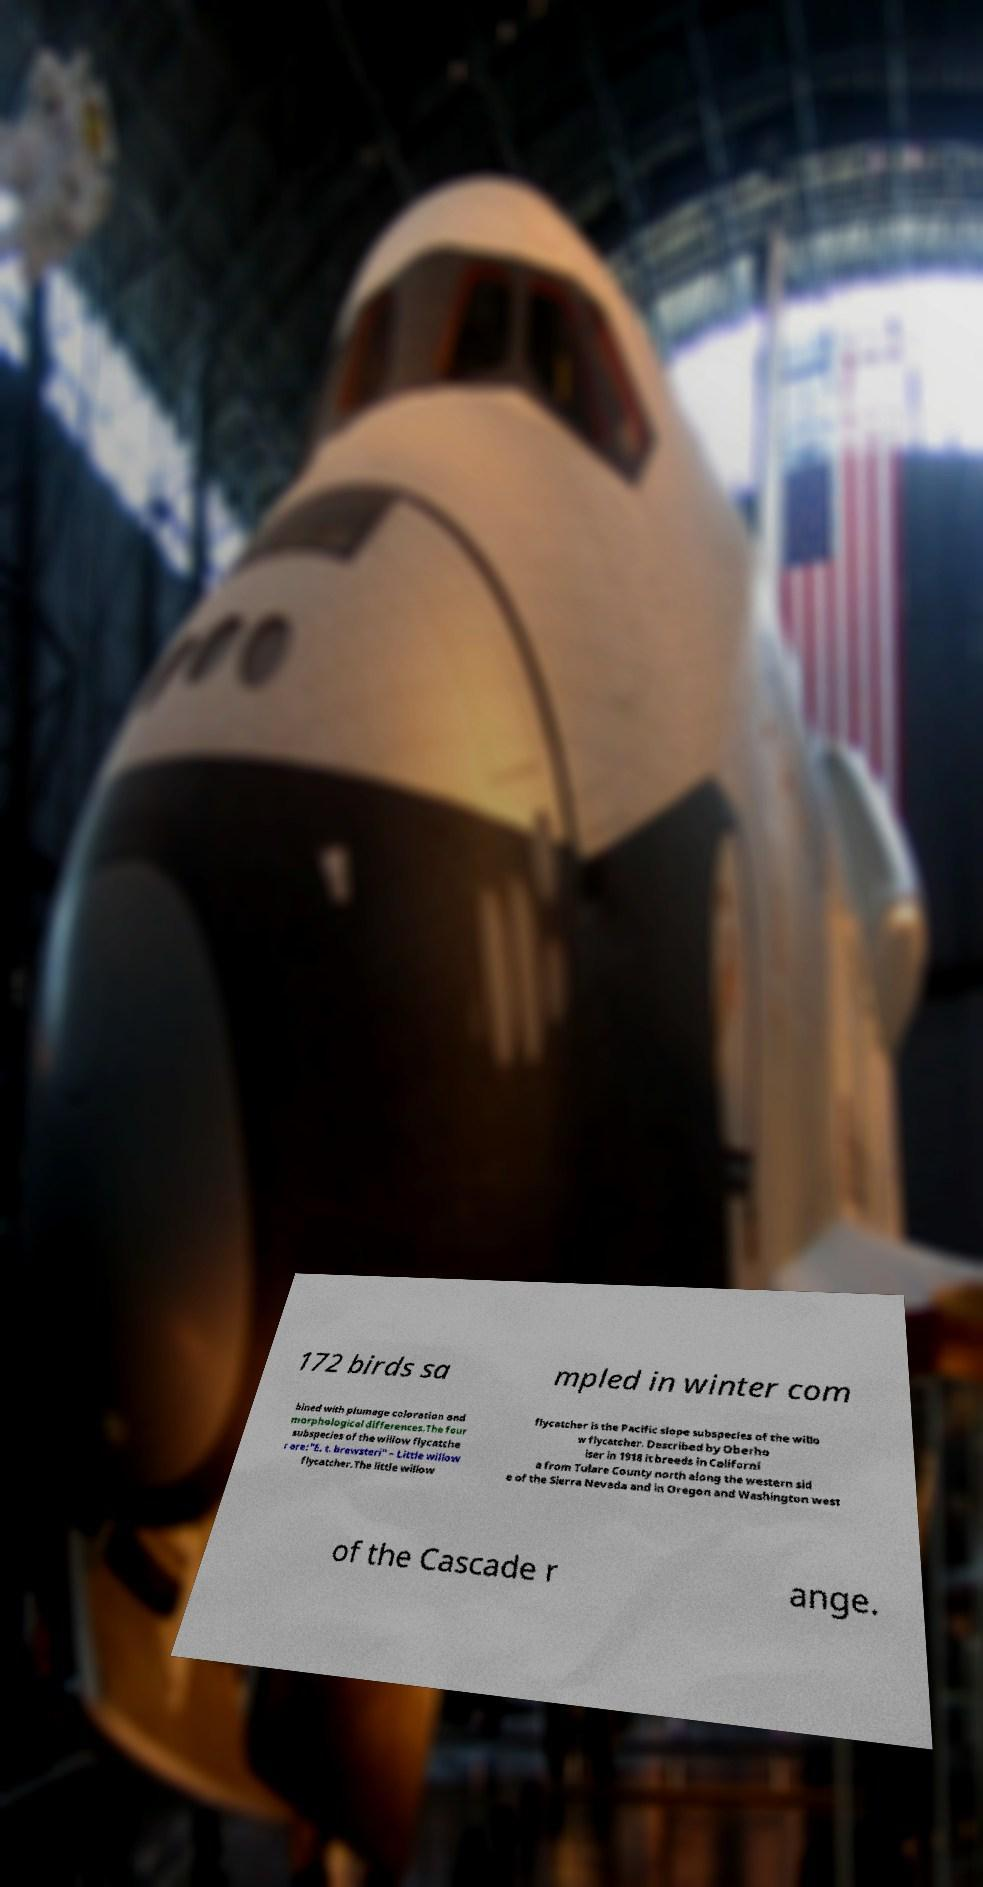Could you extract and type out the text from this image? 172 birds sa mpled in winter com bined with plumage coloration and morphological differences.The four subspecies of the willow flycatche r are:"E. t. brewsteri" – Little willow flycatcher.The little willow flycatcher is the Pacific slope subspecies of the willo w flycatcher. Described by Oberho lser in 1918 it breeds in Californi a from Tulare County north along the western sid e of the Sierra Nevada and in Oregon and Washington west of the Cascade r ange. 